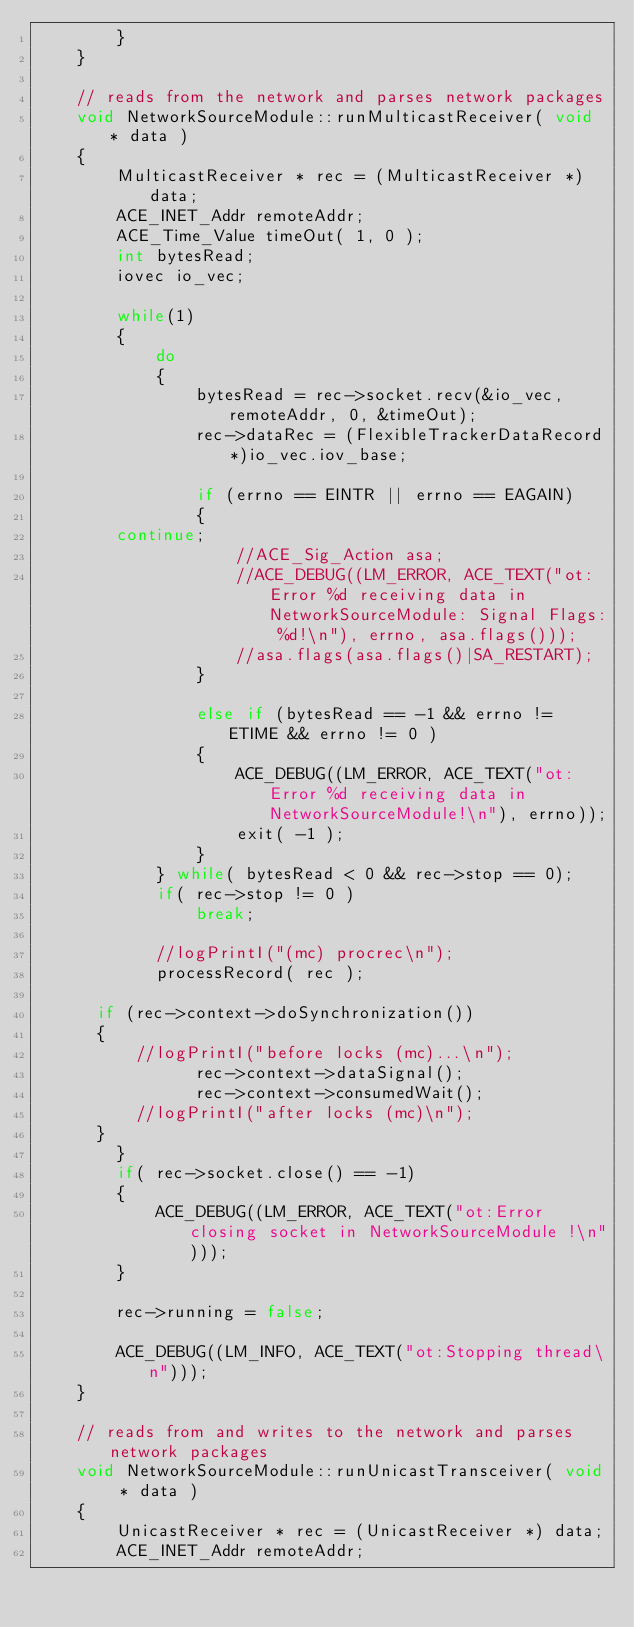Convert code to text. <code><loc_0><loc_0><loc_500><loc_500><_C++_>        }
    }

    // reads from the network and parses network packages
    void NetworkSourceModule::runMulticastReceiver( void * data )
    {
        MulticastReceiver * rec = (MulticastReceiver *) data;
        ACE_INET_Addr remoteAddr;
        ACE_Time_Value timeOut( 1, 0 );
        int bytesRead;
        iovec io_vec;

        while(1)
        {
            do
            {
                bytesRead = rec->socket.recv(&io_vec, remoteAddr, 0, &timeOut);
                rec->dataRec = (FlexibleTrackerDataRecord*)io_vec.iov_base;

                if (errno == EINTR || errno == EAGAIN)
                {
		    continue;
                    //ACE_Sig_Action asa;
                    //ACE_DEBUG((LM_ERROR, ACE_TEXT("ot:Error %d receiving data in NetworkSourceModule: Signal Flags: %d!\n"), errno, asa.flags()));
                    //asa.flags(asa.flags()|SA_RESTART);
                }
		
                else if (bytesRead == -1 && errno != ETIME && errno != 0 )
                {
                    ACE_DEBUG((LM_ERROR, ACE_TEXT("ot:Error %d receiving data in NetworkSourceModule!\n"), errno));
                    exit( -1 );
                }
            } while( bytesRead < 0 && rec->stop == 0);
            if( rec->stop != 0 )
                break;

            //logPrintI("(mc) procrec\n");
            processRecord( rec );

	    if (rec->context->doSynchronization())
	    {
	        //logPrintI("before locks (mc)...\n");
                rec->context->dataSignal();
                rec->context->consumedWait();	
	        //logPrintI("after locks (mc)\n");
	    }
        }
        if( rec->socket.close() == -1)
        {
            ACE_DEBUG((LM_ERROR, ACE_TEXT("ot:Error closing socket in NetworkSourceModule !\n")));
        }

        rec->running = false;

        ACE_DEBUG((LM_INFO, ACE_TEXT("ot:Stopping thread\n")));
    }

    // reads from and writes to the network and parses network packages
    void NetworkSourceModule::runUnicastTransceiver( void * data )
    {
        UnicastReceiver * rec = (UnicastReceiver *) data;
        ACE_INET_Addr remoteAddr;</code> 